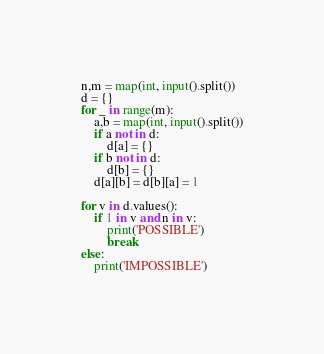Convert code to text. <code><loc_0><loc_0><loc_500><loc_500><_Python_>n,m = map(int, input().split())
d = {}
for _ in range(m):
    a,b = map(int, input().split())
    if a not in d:
        d[a] = {}
    if b not in d:
        d[b] = {}
    d[a][b] = d[b][a] = 1

for v in d.values():
    if 1 in v and n in v:
        print('POSSIBLE')
        break
else:
    print('IMPOSSIBLE')
</code> 